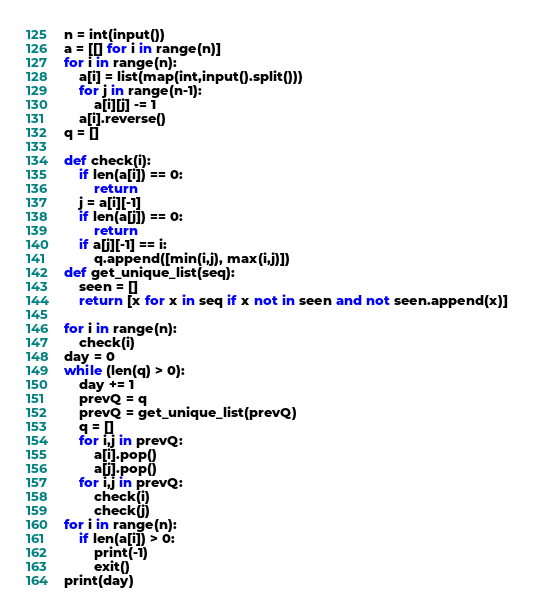Convert code to text. <code><loc_0><loc_0><loc_500><loc_500><_Python_>n = int(input())
a = [[] for i in range(n)]
for i in range(n):
    a[i] = list(map(int,input().split()))
    for j in range(n-1):
        a[i][j] -= 1
    a[i].reverse()
q = []

def check(i):
    if len(a[i]) == 0:
        return 
    j = a[i][-1]
    if len(a[j]) == 0:
        return
    if a[j][-1] == i:
        q.append([min(i,j), max(i,j)])
def get_unique_list(seq):
    seen = []
    return [x for x in seq if x not in seen and not seen.append(x)]

for i in range(n):
    check(i)
day = 0
while (len(q) > 0):
    day += 1
    prevQ = q
    prevQ = get_unique_list(prevQ)
    q = []
    for i,j in prevQ:
        a[i].pop()
        a[j].pop()
    for i,j in prevQ:
        check(i)
        check(j)
for i in range(n):
    if len(a[i]) > 0:
        print(-1)
        exit()
print(day)</code> 